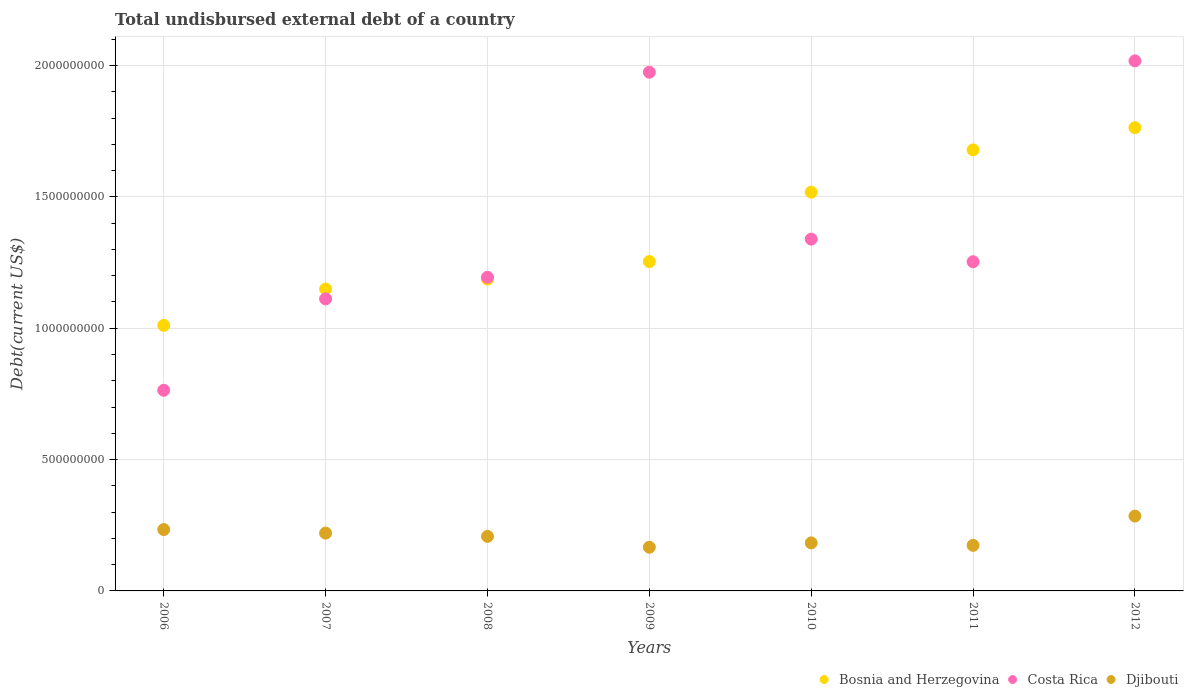Is the number of dotlines equal to the number of legend labels?
Make the answer very short. Yes. What is the total undisbursed external debt in Djibouti in 2009?
Give a very brief answer. 1.66e+08. Across all years, what is the maximum total undisbursed external debt in Costa Rica?
Your answer should be very brief. 2.02e+09. Across all years, what is the minimum total undisbursed external debt in Costa Rica?
Keep it short and to the point. 7.64e+08. What is the total total undisbursed external debt in Djibouti in the graph?
Give a very brief answer. 1.47e+09. What is the difference between the total undisbursed external debt in Djibouti in 2009 and that in 2012?
Your answer should be very brief. -1.19e+08. What is the difference between the total undisbursed external debt in Djibouti in 2007 and the total undisbursed external debt in Bosnia and Herzegovina in 2009?
Ensure brevity in your answer.  -1.03e+09. What is the average total undisbursed external debt in Bosnia and Herzegovina per year?
Provide a succinct answer. 1.37e+09. In the year 2012, what is the difference between the total undisbursed external debt in Djibouti and total undisbursed external debt in Costa Rica?
Your response must be concise. -1.73e+09. What is the ratio of the total undisbursed external debt in Djibouti in 2007 to that in 2009?
Give a very brief answer. 1.32. Is the total undisbursed external debt in Bosnia and Herzegovina in 2006 less than that in 2007?
Offer a terse response. Yes. Is the difference between the total undisbursed external debt in Djibouti in 2010 and 2011 greater than the difference between the total undisbursed external debt in Costa Rica in 2010 and 2011?
Give a very brief answer. No. What is the difference between the highest and the second highest total undisbursed external debt in Djibouti?
Your answer should be very brief. 5.14e+07. What is the difference between the highest and the lowest total undisbursed external debt in Costa Rica?
Your answer should be compact. 1.25e+09. In how many years, is the total undisbursed external debt in Bosnia and Herzegovina greater than the average total undisbursed external debt in Bosnia and Herzegovina taken over all years?
Offer a terse response. 3. Is the sum of the total undisbursed external debt in Djibouti in 2009 and 2011 greater than the maximum total undisbursed external debt in Costa Rica across all years?
Ensure brevity in your answer.  No. Is the total undisbursed external debt in Bosnia and Herzegovina strictly greater than the total undisbursed external debt in Djibouti over the years?
Make the answer very short. Yes. How many dotlines are there?
Keep it short and to the point. 3. How many years are there in the graph?
Provide a succinct answer. 7. What is the difference between two consecutive major ticks on the Y-axis?
Offer a very short reply. 5.00e+08. Are the values on the major ticks of Y-axis written in scientific E-notation?
Keep it short and to the point. No. How many legend labels are there?
Provide a succinct answer. 3. How are the legend labels stacked?
Your answer should be very brief. Horizontal. What is the title of the graph?
Make the answer very short. Total undisbursed external debt of a country. Does "Mozambique" appear as one of the legend labels in the graph?
Provide a short and direct response. No. What is the label or title of the X-axis?
Your answer should be compact. Years. What is the label or title of the Y-axis?
Offer a terse response. Debt(current US$). What is the Debt(current US$) of Bosnia and Herzegovina in 2006?
Make the answer very short. 1.01e+09. What is the Debt(current US$) of Costa Rica in 2006?
Offer a terse response. 7.64e+08. What is the Debt(current US$) of Djibouti in 2006?
Ensure brevity in your answer.  2.34e+08. What is the Debt(current US$) of Bosnia and Herzegovina in 2007?
Your answer should be compact. 1.15e+09. What is the Debt(current US$) in Costa Rica in 2007?
Your response must be concise. 1.11e+09. What is the Debt(current US$) in Djibouti in 2007?
Offer a terse response. 2.20e+08. What is the Debt(current US$) of Bosnia and Herzegovina in 2008?
Ensure brevity in your answer.  1.19e+09. What is the Debt(current US$) of Costa Rica in 2008?
Ensure brevity in your answer.  1.19e+09. What is the Debt(current US$) in Djibouti in 2008?
Your answer should be compact. 2.08e+08. What is the Debt(current US$) of Bosnia and Herzegovina in 2009?
Your response must be concise. 1.25e+09. What is the Debt(current US$) of Costa Rica in 2009?
Make the answer very short. 1.97e+09. What is the Debt(current US$) of Djibouti in 2009?
Your answer should be compact. 1.66e+08. What is the Debt(current US$) of Bosnia and Herzegovina in 2010?
Your answer should be compact. 1.52e+09. What is the Debt(current US$) of Costa Rica in 2010?
Make the answer very short. 1.34e+09. What is the Debt(current US$) in Djibouti in 2010?
Ensure brevity in your answer.  1.83e+08. What is the Debt(current US$) in Bosnia and Herzegovina in 2011?
Your answer should be very brief. 1.68e+09. What is the Debt(current US$) of Costa Rica in 2011?
Your answer should be very brief. 1.25e+09. What is the Debt(current US$) in Djibouti in 2011?
Offer a very short reply. 1.73e+08. What is the Debt(current US$) in Bosnia and Herzegovina in 2012?
Make the answer very short. 1.76e+09. What is the Debt(current US$) in Costa Rica in 2012?
Make the answer very short. 2.02e+09. What is the Debt(current US$) of Djibouti in 2012?
Provide a short and direct response. 2.85e+08. Across all years, what is the maximum Debt(current US$) of Bosnia and Herzegovina?
Offer a terse response. 1.76e+09. Across all years, what is the maximum Debt(current US$) of Costa Rica?
Your response must be concise. 2.02e+09. Across all years, what is the maximum Debt(current US$) in Djibouti?
Keep it short and to the point. 2.85e+08. Across all years, what is the minimum Debt(current US$) in Bosnia and Herzegovina?
Make the answer very short. 1.01e+09. Across all years, what is the minimum Debt(current US$) in Costa Rica?
Provide a succinct answer. 7.64e+08. Across all years, what is the minimum Debt(current US$) of Djibouti?
Keep it short and to the point. 1.66e+08. What is the total Debt(current US$) of Bosnia and Herzegovina in the graph?
Ensure brevity in your answer.  9.56e+09. What is the total Debt(current US$) of Costa Rica in the graph?
Offer a terse response. 9.65e+09. What is the total Debt(current US$) of Djibouti in the graph?
Provide a succinct answer. 1.47e+09. What is the difference between the Debt(current US$) in Bosnia and Herzegovina in 2006 and that in 2007?
Offer a very short reply. -1.38e+08. What is the difference between the Debt(current US$) in Costa Rica in 2006 and that in 2007?
Your answer should be compact. -3.48e+08. What is the difference between the Debt(current US$) of Djibouti in 2006 and that in 2007?
Your answer should be very brief. 1.34e+07. What is the difference between the Debt(current US$) of Bosnia and Herzegovina in 2006 and that in 2008?
Your answer should be compact. -1.76e+08. What is the difference between the Debt(current US$) in Costa Rica in 2006 and that in 2008?
Provide a succinct answer. -4.30e+08. What is the difference between the Debt(current US$) of Djibouti in 2006 and that in 2008?
Your answer should be very brief. 2.58e+07. What is the difference between the Debt(current US$) in Bosnia and Herzegovina in 2006 and that in 2009?
Keep it short and to the point. -2.43e+08. What is the difference between the Debt(current US$) in Costa Rica in 2006 and that in 2009?
Offer a terse response. -1.21e+09. What is the difference between the Debt(current US$) in Djibouti in 2006 and that in 2009?
Your answer should be very brief. 6.73e+07. What is the difference between the Debt(current US$) in Bosnia and Herzegovina in 2006 and that in 2010?
Offer a terse response. -5.07e+08. What is the difference between the Debt(current US$) of Costa Rica in 2006 and that in 2010?
Your answer should be compact. -5.75e+08. What is the difference between the Debt(current US$) of Djibouti in 2006 and that in 2010?
Ensure brevity in your answer.  5.07e+07. What is the difference between the Debt(current US$) of Bosnia and Herzegovina in 2006 and that in 2011?
Offer a very short reply. -6.68e+08. What is the difference between the Debt(current US$) in Costa Rica in 2006 and that in 2011?
Offer a terse response. -4.89e+08. What is the difference between the Debt(current US$) of Djibouti in 2006 and that in 2011?
Make the answer very short. 6.00e+07. What is the difference between the Debt(current US$) of Bosnia and Herzegovina in 2006 and that in 2012?
Provide a short and direct response. -7.53e+08. What is the difference between the Debt(current US$) of Costa Rica in 2006 and that in 2012?
Provide a short and direct response. -1.25e+09. What is the difference between the Debt(current US$) of Djibouti in 2006 and that in 2012?
Keep it short and to the point. -5.14e+07. What is the difference between the Debt(current US$) in Bosnia and Herzegovina in 2007 and that in 2008?
Ensure brevity in your answer.  -3.78e+07. What is the difference between the Debt(current US$) of Costa Rica in 2007 and that in 2008?
Provide a succinct answer. -8.23e+07. What is the difference between the Debt(current US$) in Djibouti in 2007 and that in 2008?
Keep it short and to the point. 1.25e+07. What is the difference between the Debt(current US$) of Bosnia and Herzegovina in 2007 and that in 2009?
Keep it short and to the point. -1.05e+08. What is the difference between the Debt(current US$) in Costa Rica in 2007 and that in 2009?
Your answer should be very brief. -8.63e+08. What is the difference between the Debt(current US$) in Djibouti in 2007 and that in 2009?
Give a very brief answer. 5.39e+07. What is the difference between the Debt(current US$) in Bosnia and Herzegovina in 2007 and that in 2010?
Give a very brief answer. -3.69e+08. What is the difference between the Debt(current US$) of Costa Rica in 2007 and that in 2010?
Offer a terse response. -2.28e+08. What is the difference between the Debt(current US$) of Djibouti in 2007 and that in 2010?
Provide a short and direct response. 3.73e+07. What is the difference between the Debt(current US$) in Bosnia and Herzegovina in 2007 and that in 2011?
Provide a succinct answer. -5.30e+08. What is the difference between the Debt(current US$) in Costa Rica in 2007 and that in 2011?
Provide a succinct answer. -1.41e+08. What is the difference between the Debt(current US$) of Djibouti in 2007 and that in 2011?
Your answer should be very brief. 4.67e+07. What is the difference between the Debt(current US$) in Bosnia and Herzegovina in 2007 and that in 2012?
Provide a succinct answer. -6.14e+08. What is the difference between the Debt(current US$) in Costa Rica in 2007 and that in 2012?
Provide a succinct answer. -9.06e+08. What is the difference between the Debt(current US$) in Djibouti in 2007 and that in 2012?
Keep it short and to the point. -6.48e+07. What is the difference between the Debt(current US$) of Bosnia and Herzegovina in 2008 and that in 2009?
Provide a succinct answer. -6.69e+07. What is the difference between the Debt(current US$) of Costa Rica in 2008 and that in 2009?
Make the answer very short. -7.80e+08. What is the difference between the Debt(current US$) in Djibouti in 2008 and that in 2009?
Ensure brevity in your answer.  4.14e+07. What is the difference between the Debt(current US$) in Bosnia and Herzegovina in 2008 and that in 2010?
Your answer should be very brief. -3.31e+08. What is the difference between the Debt(current US$) in Costa Rica in 2008 and that in 2010?
Your answer should be compact. -1.45e+08. What is the difference between the Debt(current US$) of Djibouti in 2008 and that in 2010?
Your response must be concise. 2.49e+07. What is the difference between the Debt(current US$) of Bosnia and Herzegovina in 2008 and that in 2011?
Your response must be concise. -4.92e+08. What is the difference between the Debt(current US$) in Costa Rica in 2008 and that in 2011?
Your answer should be compact. -5.90e+07. What is the difference between the Debt(current US$) in Djibouti in 2008 and that in 2011?
Ensure brevity in your answer.  3.42e+07. What is the difference between the Debt(current US$) in Bosnia and Herzegovina in 2008 and that in 2012?
Ensure brevity in your answer.  -5.77e+08. What is the difference between the Debt(current US$) of Costa Rica in 2008 and that in 2012?
Give a very brief answer. -8.24e+08. What is the difference between the Debt(current US$) in Djibouti in 2008 and that in 2012?
Ensure brevity in your answer.  -7.73e+07. What is the difference between the Debt(current US$) in Bosnia and Herzegovina in 2009 and that in 2010?
Give a very brief answer. -2.64e+08. What is the difference between the Debt(current US$) in Costa Rica in 2009 and that in 2010?
Offer a terse response. 6.35e+08. What is the difference between the Debt(current US$) in Djibouti in 2009 and that in 2010?
Ensure brevity in your answer.  -1.66e+07. What is the difference between the Debt(current US$) of Bosnia and Herzegovina in 2009 and that in 2011?
Your response must be concise. -4.25e+08. What is the difference between the Debt(current US$) in Costa Rica in 2009 and that in 2011?
Your response must be concise. 7.21e+08. What is the difference between the Debt(current US$) in Djibouti in 2009 and that in 2011?
Provide a succinct answer. -7.25e+06. What is the difference between the Debt(current US$) in Bosnia and Herzegovina in 2009 and that in 2012?
Your response must be concise. -5.10e+08. What is the difference between the Debt(current US$) in Costa Rica in 2009 and that in 2012?
Make the answer very short. -4.32e+07. What is the difference between the Debt(current US$) in Djibouti in 2009 and that in 2012?
Your response must be concise. -1.19e+08. What is the difference between the Debt(current US$) in Bosnia and Herzegovina in 2010 and that in 2011?
Offer a very short reply. -1.61e+08. What is the difference between the Debt(current US$) of Costa Rica in 2010 and that in 2011?
Your answer should be compact. 8.61e+07. What is the difference between the Debt(current US$) in Djibouti in 2010 and that in 2011?
Offer a terse response. 9.31e+06. What is the difference between the Debt(current US$) in Bosnia and Herzegovina in 2010 and that in 2012?
Your answer should be very brief. -2.46e+08. What is the difference between the Debt(current US$) in Costa Rica in 2010 and that in 2012?
Give a very brief answer. -6.79e+08. What is the difference between the Debt(current US$) of Djibouti in 2010 and that in 2012?
Offer a very short reply. -1.02e+08. What is the difference between the Debt(current US$) in Bosnia and Herzegovina in 2011 and that in 2012?
Offer a very short reply. -8.46e+07. What is the difference between the Debt(current US$) in Costa Rica in 2011 and that in 2012?
Give a very brief answer. -7.65e+08. What is the difference between the Debt(current US$) in Djibouti in 2011 and that in 2012?
Keep it short and to the point. -1.11e+08. What is the difference between the Debt(current US$) in Bosnia and Herzegovina in 2006 and the Debt(current US$) in Costa Rica in 2007?
Your answer should be very brief. -1.01e+08. What is the difference between the Debt(current US$) of Bosnia and Herzegovina in 2006 and the Debt(current US$) of Djibouti in 2007?
Offer a terse response. 7.91e+08. What is the difference between the Debt(current US$) in Costa Rica in 2006 and the Debt(current US$) in Djibouti in 2007?
Make the answer very short. 5.44e+08. What is the difference between the Debt(current US$) of Bosnia and Herzegovina in 2006 and the Debt(current US$) of Costa Rica in 2008?
Your response must be concise. -1.83e+08. What is the difference between the Debt(current US$) in Bosnia and Herzegovina in 2006 and the Debt(current US$) in Djibouti in 2008?
Make the answer very short. 8.03e+08. What is the difference between the Debt(current US$) of Costa Rica in 2006 and the Debt(current US$) of Djibouti in 2008?
Give a very brief answer. 5.56e+08. What is the difference between the Debt(current US$) in Bosnia and Herzegovina in 2006 and the Debt(current US$) in Costa Rica in 2009?
Provide a succinct answer. -9.64e+08. What is the difference between the Debt(current US$) in Bosnia and Herzegovina in 2006 and the Debt(current US$) in Djibouti in 2009?
Your answer should be very brief. 8.45e+08. What is the difference between the Debt(current US$) of Costa Rica in 2006 and the Debt(current US$) of Djibouti in 2009?
Offer a very short reply. 5.98e+08. What is the difference between the Debt(current US$) in Bosnia and Herzegovina in 2006 and the Debt(current US$) in Costa Rica in 2010?
Your answer should be very brief. -3.28e+08. What is the difference between the Debt(current US$) of Bosnia and Herzegovina in 2006 and the Debt(current US$) of Djibouti in 2010?
Your response must be concise. 8.28e+08. What is the difference between the Debt(current US$) of Costa Rica in 2006 and the Debt(current US$) of Djibouti in 2010?
Your response must be concise. 5.81e+08. What is the difference between the Debt(current US$) of Bosnia and Herzegovina in 2006 and the Debt(current US$) of Costa Rica in 2011?
Your answer should be compact. -2.42e+08. What is the difference between the Debt(current US$) in Bosnia and Herzegovina in 2006 and the Debt(current US$) in Djibouti in 2011?
Keep it short and to the point. 8.38e+08. What is the difference between the Debt(current US$) of Costa Rica in 2006 and the Debt(current US$) of Djibouti in 2011?
Offer a terse response. 5.90e+08. What is the difference between the Debt(current US$) of Bosnia and Herzegovina in 2006 and the Debt(current US$) of Costa Rica in 2012?
Your answer should be very brief. -1.01e+09. What is the difference between the Debt(current US$) of Bosnia and Herzegovina in 2006 and the Debt(current US$) of Djibouti in 2012?
Offer a very short reply. 7.26e+08. What is the difference between the Debt(current US$) of Costa Rica in 2006 and the Debt(current US$) of Djibouti in 2012?
Your answer should be compact. 4.79e+08. What is the difference between the Debt(current US$) in Bosnia and Herzegovina in 2007 and the Debt(current US$) in Costa Rica in 2008?
Ensure brevity in your answer.  -4.49e+07. What is the difference between the Debt(current US$) in Bosnia and Herzegovina in 2007 and the Debt(current US$) in Djibouti in 2008?
Give a very brief answer. 9.42e+08. What is the difference between the Debt(current US$) in Costa Rica in 2007 and the Debt(current US$) in Djibouti in 2008?
Your response must be concise. 9.04e+08. What is the difference between the Debt(current US$) of Bosnia and Herzegovina in 2007 and the Debt(current US$) of Costa Rica in 2009?
Provide a short and direct response. -8.25e+08. What is the difference between the Debt(current US$) in Bosnia and Herzegovina in 2007 and the Debt(current US$) in Djibouti in 2009?
Ensure brevity in your answer.  9.83e+08. What is the difference between the Debt(current US$) in Costa Rica in 2007 and the Debt(current US$) in Djibouti in 2009?
Provide a short and direct response. 9.46e+08. What is the difference between the Debt(current US$) in Bosnia and Herzegovina in 2007 and the Debt(current US$) in Costa Rica in 2010?
Keep it short and to the point. -1.90e+08. What is the difference between the Debt(current US$) of Bosnia and Herzegovina in 2007 and the Debt(current US$) of Djibouti in 2010?
Your response must be concise. 9.66e+08. What is the difference between the Debt(current US$) of Costa Rica in 2007 and the Debt(current US$) of Djibouti in 2010?
Offer a terse response. 9.29e+08. What is the difference between the Debt(current US$) of Bosnia and Herzegovina in 2007 and the Debt(current US$) of Costa Rica in 2011?
Your answer should be very brief. -1.04e+08. What is the difference between the Debt(current US$) of Bosnia and Herzegovina in 2007 and the Debt(current US$) of Djibouti in 2011?
Offer a terse response. 9.76e+08. What is the difference between the Debt(current US$) of Costa Rica in 2007 and the Debt(current US$) of Djibouti in 2011?
Your answer should be very brief. 9.38e+08. What is the difference between the Debt(current US$) in Bosnia and Herzegovina in 2007 and the Debt(current US$) in Costa Rica in 2012?
Your response must be concise. -8.69e+08. What is the difference between the Debt(current US$) of Bosnia and Herzegovina in 2007 and the Debt(current US$) of Djibouti in 2012?
Your answer should be compact. 8.64e+08. What is the difference between the Debt(current US$) of Costa Rica in 2007 and the Debt(current US$) of Djibouti in 2012?
Provide a short and direct response. 8.27e+08. What is the difference between the Debt(current US$) in Bosnia and Herzegovina in 2008 and the Debt(current US$) in Costa Rica in 2009?
Offer a terse response. -7.88e+08. What is the difference between the Debt(current US$) in Bosnia and Herzegovina in 2008 and the Debt(current US$) in Djibouti in 2009?
Keep it short and to the point. 1.02e+09. What is the difference between the Debt(current US$) of Costa Rica in 2008 and the Debt(current US$) of Djibouti in 2009?
Give a very brief answer. 1.03e+09. What is the difference between the Debt(current US$) in Bosnia and Herzegovina in 2008 and the Debt(current US$) in Costa Rica in 2010?
Give a very brief answer. -1.52e+08. What is the difference between the Debt(current US$) in Bosnia and Herzegovina in 2008 and the Debt(current US$) in Djibouti in 2010?
Provide a short and direct response. 1.00e+09. What is the difference between the Debt(current US$) in Costa Rica in 2008 and the Debt(current US$) in Djibouti in 2010?
Give a very brief answer. 1.01e+09. What is the difference between the Debt(current US$) in Bosnia and Herzegovina in 2008 and the Debt(current US$) in Costa Rica in 2011?
Ensure brevity in your answer.  -6.62e+07. What is the difference between the Debt(current US$) of Bosnia and Herzegovina in 2008 and the Debt(current US$) of Djibouti in 2011?
Give a very brief answer. 1.01e+09. What is the difference between the Debt(current US$) of Costa Rica in 2008 and the Debt(current US$) of Djibouti in 2011?
Make the answer very short. 1.02e+09. What is the difference between the Debt(current US$) in Bosnia and Herzegovina in 2008 and the Debt(current US$) in Costa Rica in 2012?
Keep it short and to the point. -8.31e+08. What is the difference between the Debt(current US$) in Bosnia and Herzegovina in 2008 and the Debt(current US$) in Djibouti in 2012?
Make the answer very short. 9.02e+08. What is the difference between the Debt(current US$) in Costa Rica in 2008 and the Debt(current US$) in Djibouti in 2012?
Ensure brevity in your answer.  9.09e+08. What is the difference between the Debt(current US$) in Bosnia and Herzegovina in 2009 and the Debt(current US$) in Costa Rica in 2010?
Ensure brevity in your answer.  -8.55e+07. What is the difference between the Debt(current US$) in Bosnia and Herzegovina in 2009 and the Debt(current US$) in Djibouti in 2010?
Ensure brevity in your answer.  1.07e+09. What is the difference between the Debt(current US$) in Costa Rica in 2009 and the Debt(current US$) in Djibouti in 2010?
Your response must be concise. 1.79e+09. What is the difference between the Debt(current US$) of Bosnia and Herzegovina in 2009 and the Debt(current US$) of Costa Rica in 2011?
Make the answer very short. 6.72e+05. What is the difference between the Debt(current US$) in Bosnia and Herzegovina in 2009 and the Debt(current US$) in Djibouti in 2011?
Give a very brief answer. 1.08e+09. What is the difference between the Debt(current US$) in Costa Rica in 2009 and the Debt(current US$) in Djibouti in 2011?
Your answer should be very brief. 1.80e+09. What is the difference between the Debt(current US$) in Bosnia and Herzegovina in 2009 and the Debt(current US$) in Costa Rica in 2012?
Your response must be concise. -7.64e+08. What is the difference between the Debt(current US$) in Bosnia and Herzegovina in 2009 and the Debt(current US$) in Djibouti in 2012?
Give a very brief answer. 9.69e+08. What is the difference between the Debt(current US$) in Costa Rica in 2009 and the Debt(current US$) in Djibouti in 2012?
Your response must be concise. 1.69e+09. What is the difference between the Debt(current US$) in Bosnia and Herzegovina in 2010 and the Debt(current US$) in Costa Rica in 2011?
Keep it short and to the point. 2.65e+08. What is the difference between the Debt(current US$) in Bosnia and Herzegovina in 2010 and the Debt(current US$) in Djibouti in 2011?
Offer a very short reply. 1.34e+09. What is the difference between the Debt(current US$) of Costa Rica in 2010 and the Debt(current US$) of Djibouti in 2011?
Offer a terse response. 1.17e+09. What is the difference between the Debt(current US$) of Bosnia and Herzegovina in 2010 and the Debt(current US$) of Costa Rica in 2012?
Keep it short and to the point. -5.00e+08. What is the difference between the Debt(current US$) of Bosnia and Herzegovina in 2010 and the Debt(current US$) of Djibouti in 2012?
Give a very brief answer. 1.23e+09. What is the difference between the Debt(current US$) of Costa Rica in 2010 and the Debt(current US$) of Djibouti in 2012?
Give a very brief answer. 1.05e+09. What is the difference between the Debt(current US$) in Bosnia and Herzegovina in 2011 and the Debt(current US$) in Costa Rica in 2012?
Your answer should be very brief. -3.39e+08. What is the difference between the Debt(current US$) of Bosnia and Herzegovina in 2011 and the Debt(current US$) of Djibouti in 2012?
Give a very brief answer. 1.39e+09. What is the difference between the Debt(current US$) of Costa Rica in 2011 and the Debt(current US$) of Djibouti in 2012?
Your response must be concise. 9.68e+08. What is the average Debt(current US$) of Bosnia and Herzegovina per year?
Provide a succinct answer. 1.37e+09. What is the average Debt(current US$) of Costa Rica per year?
Ensure brevity in your answer.  1.38e+09. What is the average Debt(current US$) in Djibouti per year?
Your answer should be compact. 2.10e+08. In the year 2006, what is the difference between the Debt(current US$) of Bosnia and Herzegovina and Debt(current US$) of Costa Rica?
Make the answer very short. 2.47e+08. In the year 2006, what is the difference between the Debt(current US$) of Bosnia and Herzegovina and Debt(current US$) of Djibouti?
Your answer should be very brief. 7.77e+08. In the year 2006, what is the difference between the Debt(current US$) in Costa Rica and Debt(current US$) in Djibouti?
Keep it short and to the point. 5.30e+08. In the year 2007, what is the difference between the Debt(current US$) of Bosnia and Herzegovina and Debt(current US$) of Costa Rica?
Ensure brevity in your answer.  3.74e+07. In the year 2007, what is the difference between the Debt(current US$) in Bosnia and Herzegovina and Debt(current US$) in Djibouti?
Offer a terse response. 9.29e+08. In the year 2007, what is the difference between the Debt(current US$) in Costa Rica and Debt(current US$) in Djibouti?
Offer a terse response. 8.92e+08. In the year 2008, what is the difference between the Debt(current US$) in Bosnia and Herzegovina and Debt(current US$) in Costa Rica?
Offer a terse response. -7.15e+06. In the year 2008, what is the difference between the Debt(current US$) in Bosnia and Herzegovina and Debt(current US$) in Djibouti?
Offer a very short reply. 9.79e+08. In the year 2008, what is the difference between the Debt(current US$) in Costa Rica and Debt(current US$) in Djibouti?
Make the answer very short. 9.86e+08. In the year 2009, what is the difference between the Debt(current US$) in Bosnia and Herzegovina and Debt(current US$) in Costa Rica?
Keep it short and to the point. -7.21e+08. In the year 2009, what is the difference between the Debt(current US$) in Bosnia and Herzegovina and Debt(current US$) in Djibouti?
Your response must be concise. 1.09e+09. In the year 2009, what is the difference between the Debt(current US$) of Costa Rica and Debt(current US$) of Djibouti?
Make the answer very short. 1.81e+09. In the year 2010, what is the difference between the Debt(current US$) of Bosnia and Herzegovina and Debt(current US$) of Costa Rica?
Provide a succinct answer. 1.79e+08. In the year 2010, what is the difference between the Debt(current US$) of Bosnia and Herzegovina and Debt(current US$) of Djibouti?
Give a very brief answer. 1.34e+09. In the year 2010, what is the difference between the Debt(current US$) in Costa Rica and Debt(current US$) in Djibouti?
Give a very brief answer. 1.16e+09. In the year 2011, what is the difference between the Debt(current US$) of Bosnia and Herzegovina and Debt(current US$) of Costa Rica?
Offer a very short reply. 4.26e+08. In the year 2011, what is the difference between the Debt(current US$) in Bosnia and Herzegovina and Debt(current US$) in Djibouti?
Your answer should be compact. 1.51e+09. In the year 2011, what is the difference between the Debt(current US$) of Costa Rica and Debt(current US$) of Djibouti?
Provide a succinct answer. 1.08e+09. In the year 2012, what is the difference between the Debt(current US$) in Bosnia and Herzegovina and Debt(current US$) in Costa Rica?
Your answer should be very brief. -2.54e+08. In the year 2012, what is the difference between the Debt(current US$) in Bosnia and Herzegovina and Debt(current US$) in Djibouti?
Offer a very short reply. 1.48e+09. In the year 2012, what is the difference between the Debt(current US$) of Costa Rica and Debt(current US$) of Djibouti?
Give a very brief answer. 1.73e+09. What is the ratio of the Debt(current US$) of Bosnia and Herzegovina in 2006 to that in 2007?
Your answer should be very brief. 0.88. What is the ratio of the Debt(current US$) of Costa Rica in 2006 to that in 2007?
Provide a succinct answer. 0.69. What is the ratio of the Debt(current US$) in Djibouti in 2006 to that in 2007?
Your response must be concise. 1.06. What is the ratio of the Debt(current US$) of Bosnia and Herzegovina in 2006 to that in 2008?
Ensure brevity in your answer.  0.85. What is the ratio of the Debt(current US$) of Costa Rica in 2006 to that in 2008?
Your response must be concise. 0.64. What is the ratio of the Debt(current US$) in Djibouti in 2006 to that in 2008?
Offer a terse response. 1.12. What is the ratio of the Debt(current US$) of Bosnia and Herzegovina in 2006 to that in 2009?
Your answer should be very brief. 0.81. What is the ratio of the Debt(current US$) of Costa Rica in 2006 to that in 2009?
Ensure brevity in your answer.  0.39. What is the ratio of the Debt(current US$) in Djibouti in 2006 to that in 2009?
Your answer should be very brief. 1.4. What is the ratio of the Debt(current US$) in Bosnia and Herzegovina in 2006 to that in 2010?
Provide a short and direct response. 0.67. What is the ratio of the Debt(current US$) in Costa Rica in 2006 to that in 2010?
Provide a succinct answer. 0.57. What is the ratio of the Debt(current US$) in Djibouti in 2006 to that in 2010?
Give a very brief answer. 1.28. What is the ratio of the Debt(current US$) of Bosnia and Herzegovina in 2006 to that in 2011?
Provide a succinct answer. 0.6. What is the ratio of the Debt(current US$) in Costa Rica in 2006 to that in 2011?
Provide a short and direct response. 0.61. What is the ratio of the Debt(current US$) of Djibouti in 2006 to that in 2011?
Your answer should be very brief. 1.35. What is the ratio of the Debt(current US$) in Bosnia and Herzegovina in 2006 to that in 2012?
Make the answer very short. 0.57. What is the ratio of the Debt(current US$) in Costa Rica in 2006 to that in 2012?
Your response must be concise. 0.38. What is the ratio of the Debt(current US$) in Djibouti in 2006 to that in 2012?
Provide a succinct answer. 0.82. What is the ratio of the Debt(current US$) in Bosnia and Herzegovina in 2007 to that in 2008?
Provide a short and direct response. 0.97. What is the ratio of the Debt(current US$) in Costa Rica in 2007 to that in 2008?
Provide a short and direct response. 0.93. What is the ratio of the Debt(current US$) of Djibouti in 2007 to that in 2008?
Offer a very short reply. 1.06. What is the ratio of the Debt(current US$) of Bosnia and Herzegovina in 2007 to that in 2009?
Make the answer very short. 0.92. What is the ratio of the Debt(current US$) of Costa Rica in 2007 to that in 2009?
Offer a terse response. 0.56. What is the ratio of the Debt(current US$) of Djibouti in 2007 to that in 2009?
Your answer should be compact. 1.32. What is the ratio of the Debt(current US$) in Bosnia and Herzegovina in 2007 to that in 2010?
Your response must be concise. 0.76. What is the ratio of the Debt(current US$) of Costa Rica in 2007 to that in 2010?
Give a very brief answer. 0.83. What is the ratio of the Debt(current US$) of Djibouti in 2007 to that in 2010?
Your response must be concise. 1.2. What is the ratio of the Debt(current US$) in Bosnia and Herzegovina in 2007 to that in 2011?
Make the answer very short. 0.68. What is the ratio of the Debt(current US$) in Costa Rica in 2007 to that in 2011?
Offer a very short reply. 0.89. What is the ratio of the Debt(current US$) in Djibouti in 2007 to that in 2011?
Keep it short and to the point. 1.27. What is the ratio of the Debt(current US$) in Bosnia and Herzegovina in 2007 to that in 2012?
Provide a succinct answer. 0.65. What is the ratio of the Debt(current US$) of Costa Rica in 2007 to that in 2012?
Give a very brief answer. 0.55. What is the ratio of the Debt(current US$) in Djibouti in 2007 to that in 2012?
Offer a terse response. 0.77. What is the ratio of the Debt(current US$) in Bosnia and Herzegovina in 2008 to that in 2009?
Provide a short and direct response. 0.95. What is the ratio of the Debt(current US$) in Costa Rica in 2008 to that in 2009?
Make the answer very short. 0.6. What is the ratio of the Debt(current US$) in Djibouti in 2008 to that in 2009?
Offer a terse response. 1.25. What is the ratio of the Debt(current US$) of Bosnia and Herzegovina in 2008 to that in 2010?
Give a very brief answer. 0.78. What is the ratio of the Debt(current US$) of Costa Rica in 2008 to that in 2010?
Keep it short and to the point. 0.89. What is the ratio of the Debt(current US$) in Djibouti in 2008 to that in 2010?
Your answer should be compact. 1.14. What is the ratio of the Debt(current US$) in Bosnia and Herzegovina in 2008 to that in 2011?
Provide a succinct answer. 0.71. What is the ratio of the Debt(current US$) in Costa Rica in 2008 to that in 2011?
Your response must be concise. 0.95. What is the ratio of the Debt(current US$) of Djibouti in 2008 to that in 2011?
Make the answer very short. 1.2. What is the ratio of the Debt(current US$) of Bosnia and Herzegovina in 2008 to that in 2012?
Ensure brevity in your answer.  0.67. What is the ratio of the Debt(current US$) of Costa Rica in 2008 to that in 2012?
Provide a short and direct response. 0.59. What is the ratio of the Debt(current US$) of Djibouti in 2008 to that in 2012?
Your answer should be compact. 0.73. What is the ratio of the Debt(current US$) of Bosnia and Herzegovina in 2009 to that in 2010?
Your answer should be very brief. 0.83. What is the ratio of the Debt(current US$) in Costa Rica in 2009 to that in 2010?
Offer a very short reply. 1.47. What is the ratio of the Debt(current US$) in Djibouti in 2009 to that in 2010?
Keep it short and to the point. 0.91. What is the ratio of the Debt(current US$) of Bosnia and Herzegovina in 2009 to that in 2011?
Give a very brief answer. 0.75. What is the ratio of the Debt(current US$) of Costa Rica in 2009 to that in 2011?
Give a very brief answer. 1.58. What is the ratio of the Debt(current US$) in Djibouti in 2009 to that in 2011?
Your response must be concise. 0.96. What is the ratio of the Debt(current US$) of Bosnia and Herzegovina in 2009 to that in 2012?
Offer a terse response. 0.71. What is the ratio of the Debt(current US$) of Costa Rica in 2009 to that in 2012?
Your answer should be very brief. 0.98. What is the ratio of the Debt(current US$) of Djibouti in 2009 to that in 2012?
Provide a short and direct response. 0.58. What is the ratio of the Debt(current US$) in Bosnia and Herzegovina in 2010 to that in 2011?
Your answer should be compact. 0.9. What is the ratio of the Debt(current US$) in Costa Rica in 2010 to that in 2011?
Your answer should be compact. 1.07. What is the ratio of the Debt(current US$) in Djibouti in 2010 to that in 2011?
Provide a short and direct response. 1.05. What is the ratio of the Debt(current US$) of Bosnia and Herzegovina in 2010 to that in 2012?
Give a very brief answer. 0.86. What is the ratio of the Debt(current US$) in Costa Rica in 2010 to that in 2012?
Ensure brevity in your answer.  0.66. What is the ratio of the Debt(current US$) in Djibouti in 2010 to that in 2012?
Give a very brief answer. 0.64. What is the ratio of the Debt(current US$) in Bosnia and Herzegovina in 2011 to that in 2012?
Your answer should be very brief. 0.95. What is the ratio of the Debt(current US$) of Costa Rica in 2011 to that in 2012?
Offer a very short reply. 0.62. What is the ratio of the Debt(current US$) of Djibouti in 2011 to that in 2012?
Provide a succinct answer. 0.61. What is the difference between the highest and the second highest Debt(current US$) of Bosnia and Herzegovina?
Make the answer very short. 8.46e+07. What is the difference between the highest and the second highest Debt(current US$) of Costa Rica?
Offer a very short reply. 4.32e+07. What is the difference between the highest and the second highest Debt(current US$) in Djibouti?
Your answer should be compact. 5.14e+07. What is the difference between the highest and the lowest Debt(current US$) of Bosnia and Herzegovina?
Your response must be concise. 7.53e+08. What is the difference between the highest and the lowest Debt(current US$) of Costa Rica?
Your response must be concise. 1.25e+09. What is the difference between the highest and the lowest Debt(current US$) in Djibouti?
Keep it short and to the point. 1.19e+08. 